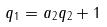Convert formula to latex. <formula><loc_0><loc_0><loc_500><loc_500>q _ { 1 } = a _ { 2 } q _ { 2 } + 1</formula> 